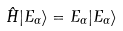Convert formula to latex. <formula><loc_0><loc_0><loc_500><loc_500>\hat { H } | E _ { \alpha } \rangle = E _ { \alpha } | E _ { \alpha } \rangle</formula> 